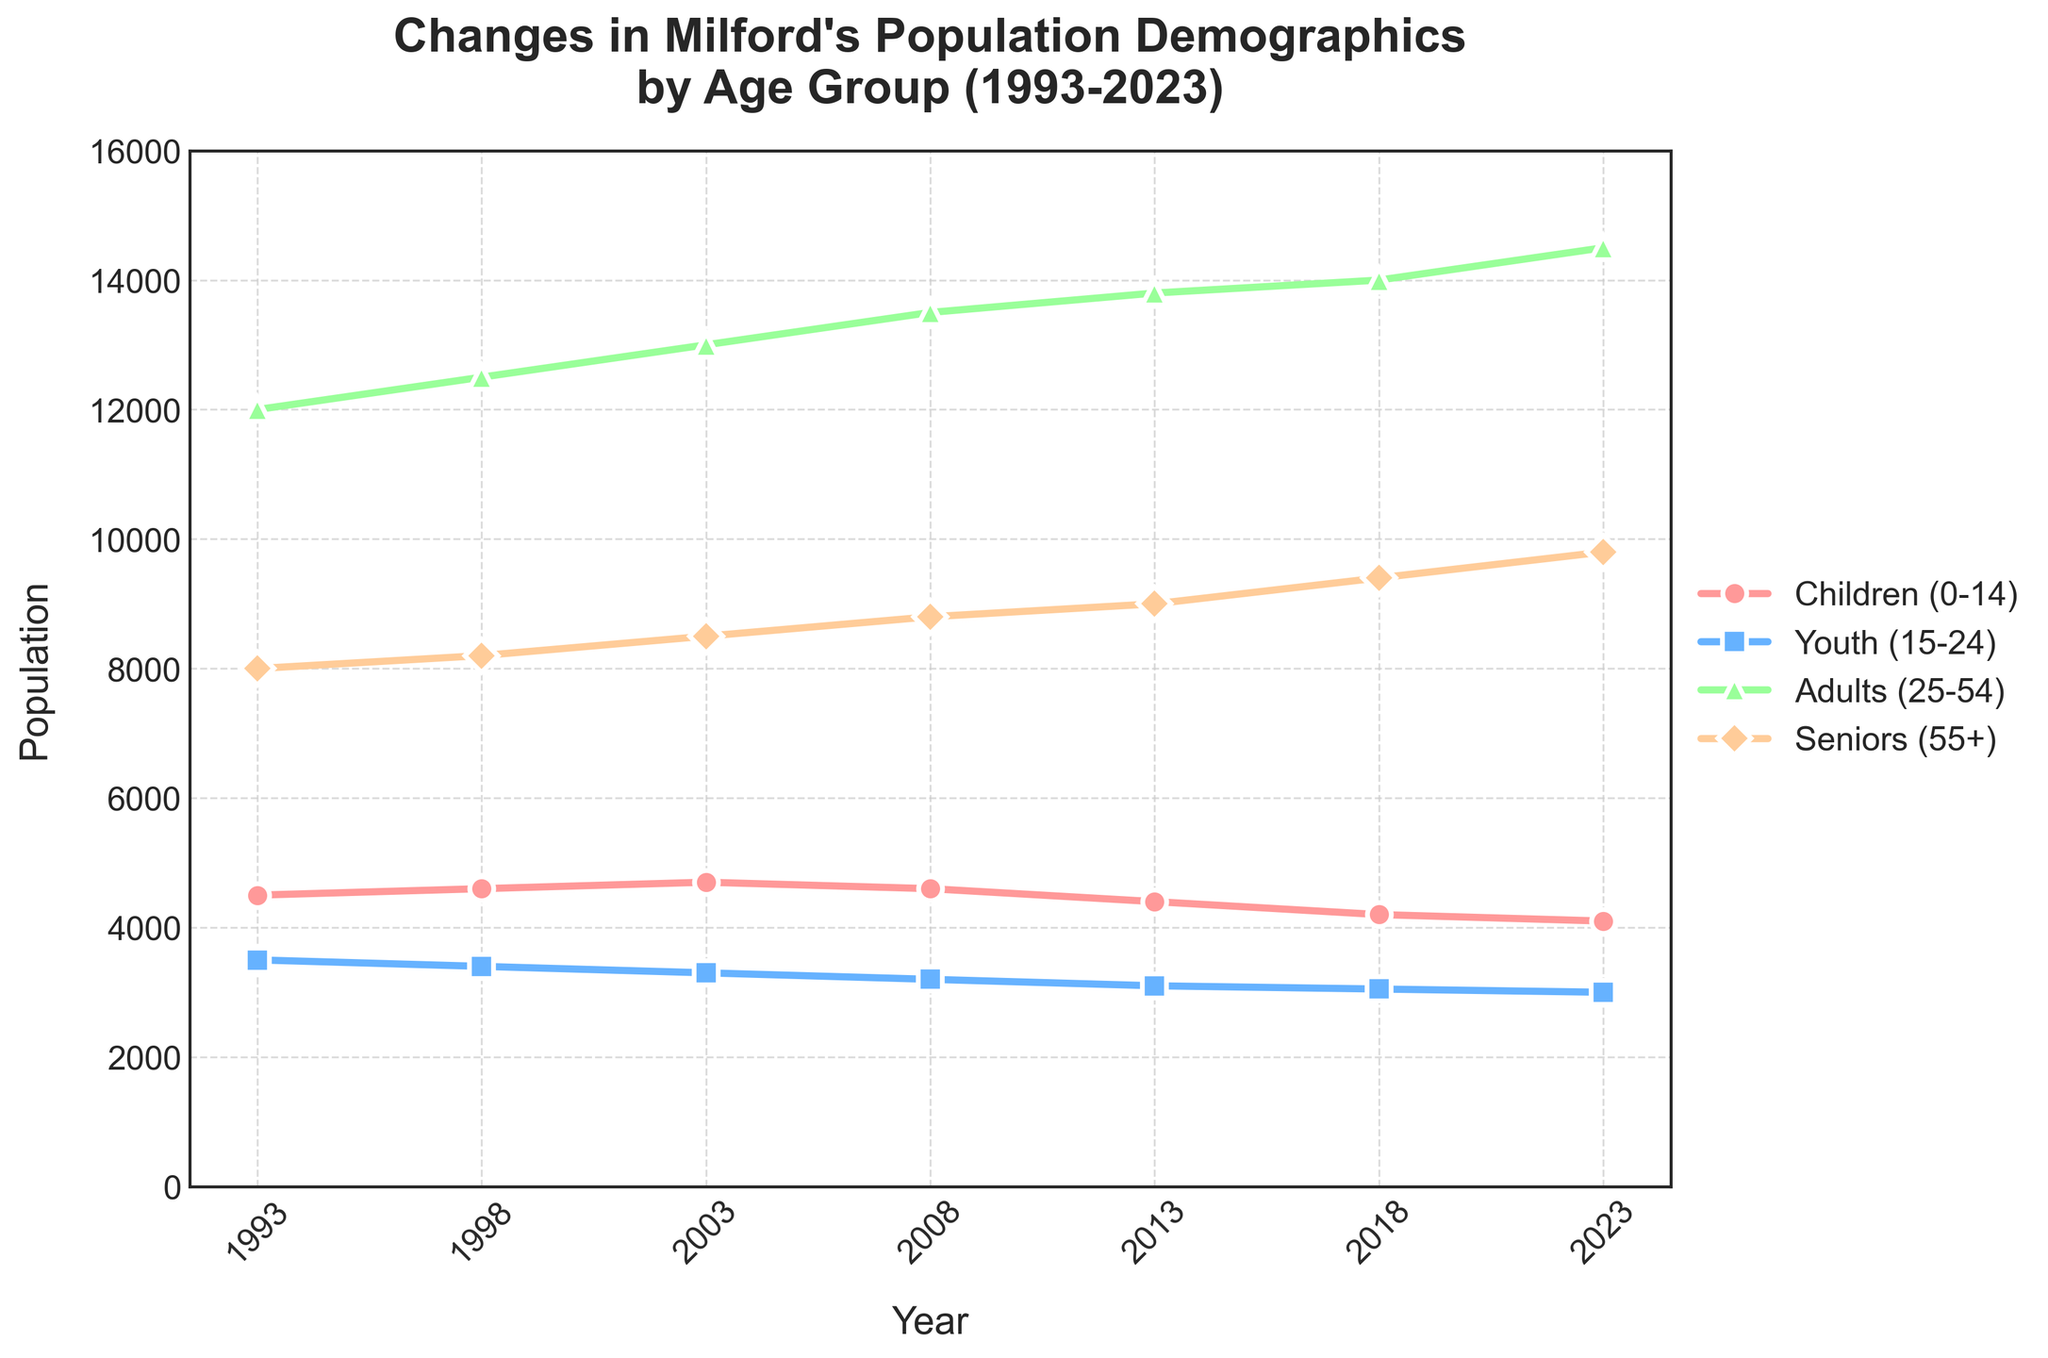What's the title of the figure? The title of the figure is usually displayed at the top and summarizes the main subject of the plot. Here, it states "Changes in Milford's Population Demographics by Age Group (1993-2023)"
Answer: Changes in Milford's Population Demographics by Age Group (1993-2023) Which age group saw the highest increase in population from 1993 to 2023? To determine the highest increase, subtract the 1993 value from the 2023 value for each age group. Adults (25-54) increased from 12000 to 14500, giving a 2500 increase, which is the largest among the groups.
Answer: Adults (25-54) How did the population of children (0-14) change over the 30-year period? By observing the starting and ending values for children (0-14): it starts at 4500 in 1993 and decreases to 4100 in 2023. Thus, the population decreased.
Answer: Decreased In which year did the adult (25-54) population cross the 13000 threshold? By examining the values for the adult population, it first reaches 13500 in 2008, marking the year it crosses the 13000 threshold.
Answer: 2008 What is the general trend in the population of seniors (55+) from 1993 to 2023? The population of seniors (55+) consistently increases over the 30-year period, starting at 8000 in 1993 and reaching 9800 in 2023.
Answer: Increasing In which years did the youth (15-24) population experience a decrease? By comparing consecutive years, we see that the youth population decreased between 1993-1998, 1998-2003, 2003-2008, 2008-2013, and 2013-2018.
Answer: 1993-1998, 1998-2003, 2003-2008, 2008-2013, 2013-2018 How many age groups had a higher population in 2023 than in 1993? By comparing the 2023 values with the 1993 values: Children (0-14) decreased, Youth (15-24) decreased, Adults (25-54) increased, Seniors (55+) increased. Thus, two age groups had a higher population.
Answer: Two Which age group shows the most stable population over the period, with the least fluctuations? By observing the variations in population, the youth (15-24) group shows the smallest changes over the years, fluctuating only slightly from 3500 to 3000.
Answer: Youth (15-24) What could be a possible reason for the increasing trend in the senior population (55+)? The increasing trend seen in the figure is likely due to the aging of previous generations and improved life expectancy over the years.
Answer: Aging and improved life expectancy 